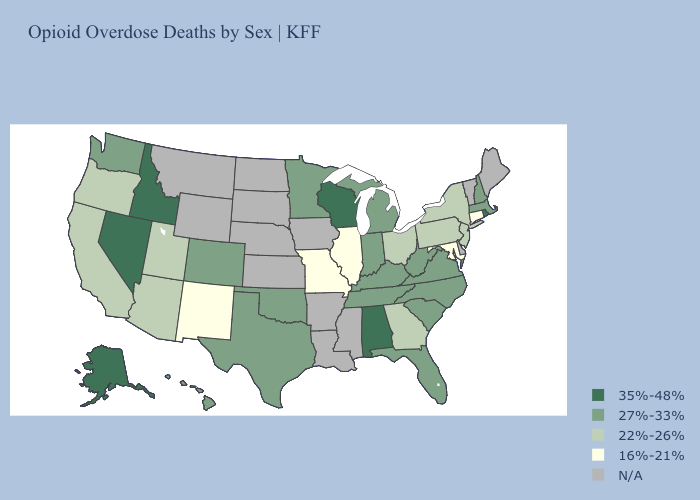Name the states that have a value in the range 35%-48%?
Keep it brief. Alabama, Alaska, Idaho, Nevada, Rhode Island, Wisconsin. What is the lowest value in the USA?
Quick response, please. 16%-21%. Which states have the highest value in the USA?
Answer briefly. Alabama, Alaska, Idaho, Nevada, Rhode Island, Wisconsin. What is the value of New Jersey?
Write a very short answer. 22%-26%. Name the states that have a value in the range 35%-48%?
Answer briefly. Alabama, Alaska, Idaho, Nevada, Rhode Island, Wisconsin. What is the value of North Dakota?
Keep it brief. N/A. Name the states that have a value in the range 22%-26%?
Give a very brief answer. Arizona, California, Georgia, New Jersey, New York, Ohio, Oregon, Pennsylvania, Utah. Which states have the lowest value in the MidWest?
Short answer required. Illinois, Missouri. Name the states that have a value in the range 22%-26%?
Short answer required. Arizona, California, Georgia, New Jersey, New York, Ohio, Oregon, Pennsylvania, Utah. What is the highest value in states that border California?
Keep it brief. 35%-48%. What is the highest value in states that border Alabama?
Answer briefly. 27%-33%. Is the legend a continuous bar?
Be succinct. No. Does the map have missing data?
Concise answer only. Yes. 